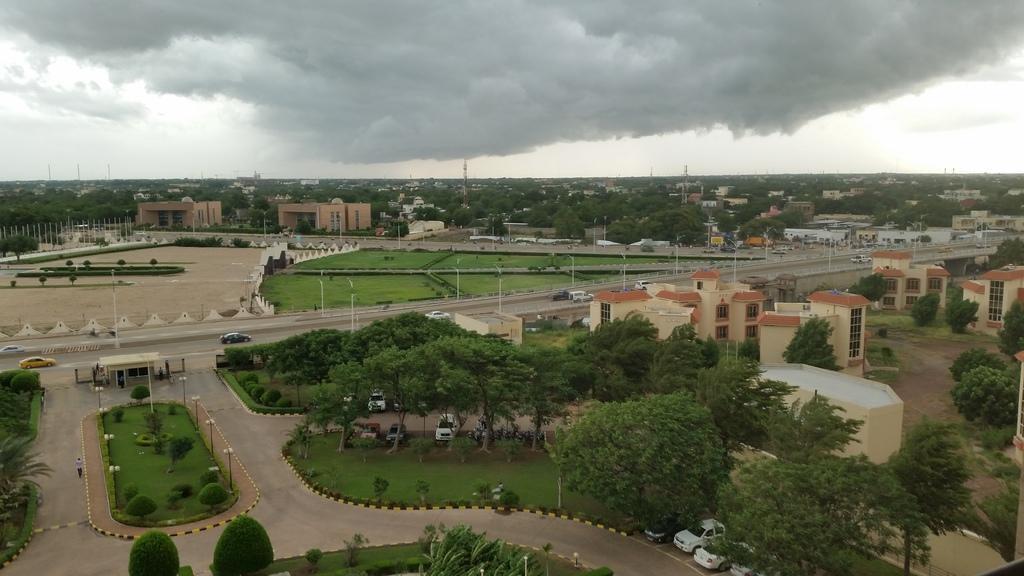Please provide a concise description of this image. These are the trees, there are vehicles that are parked under these trees. In the right side, there are buildings at the top it's a cloudy sky. 